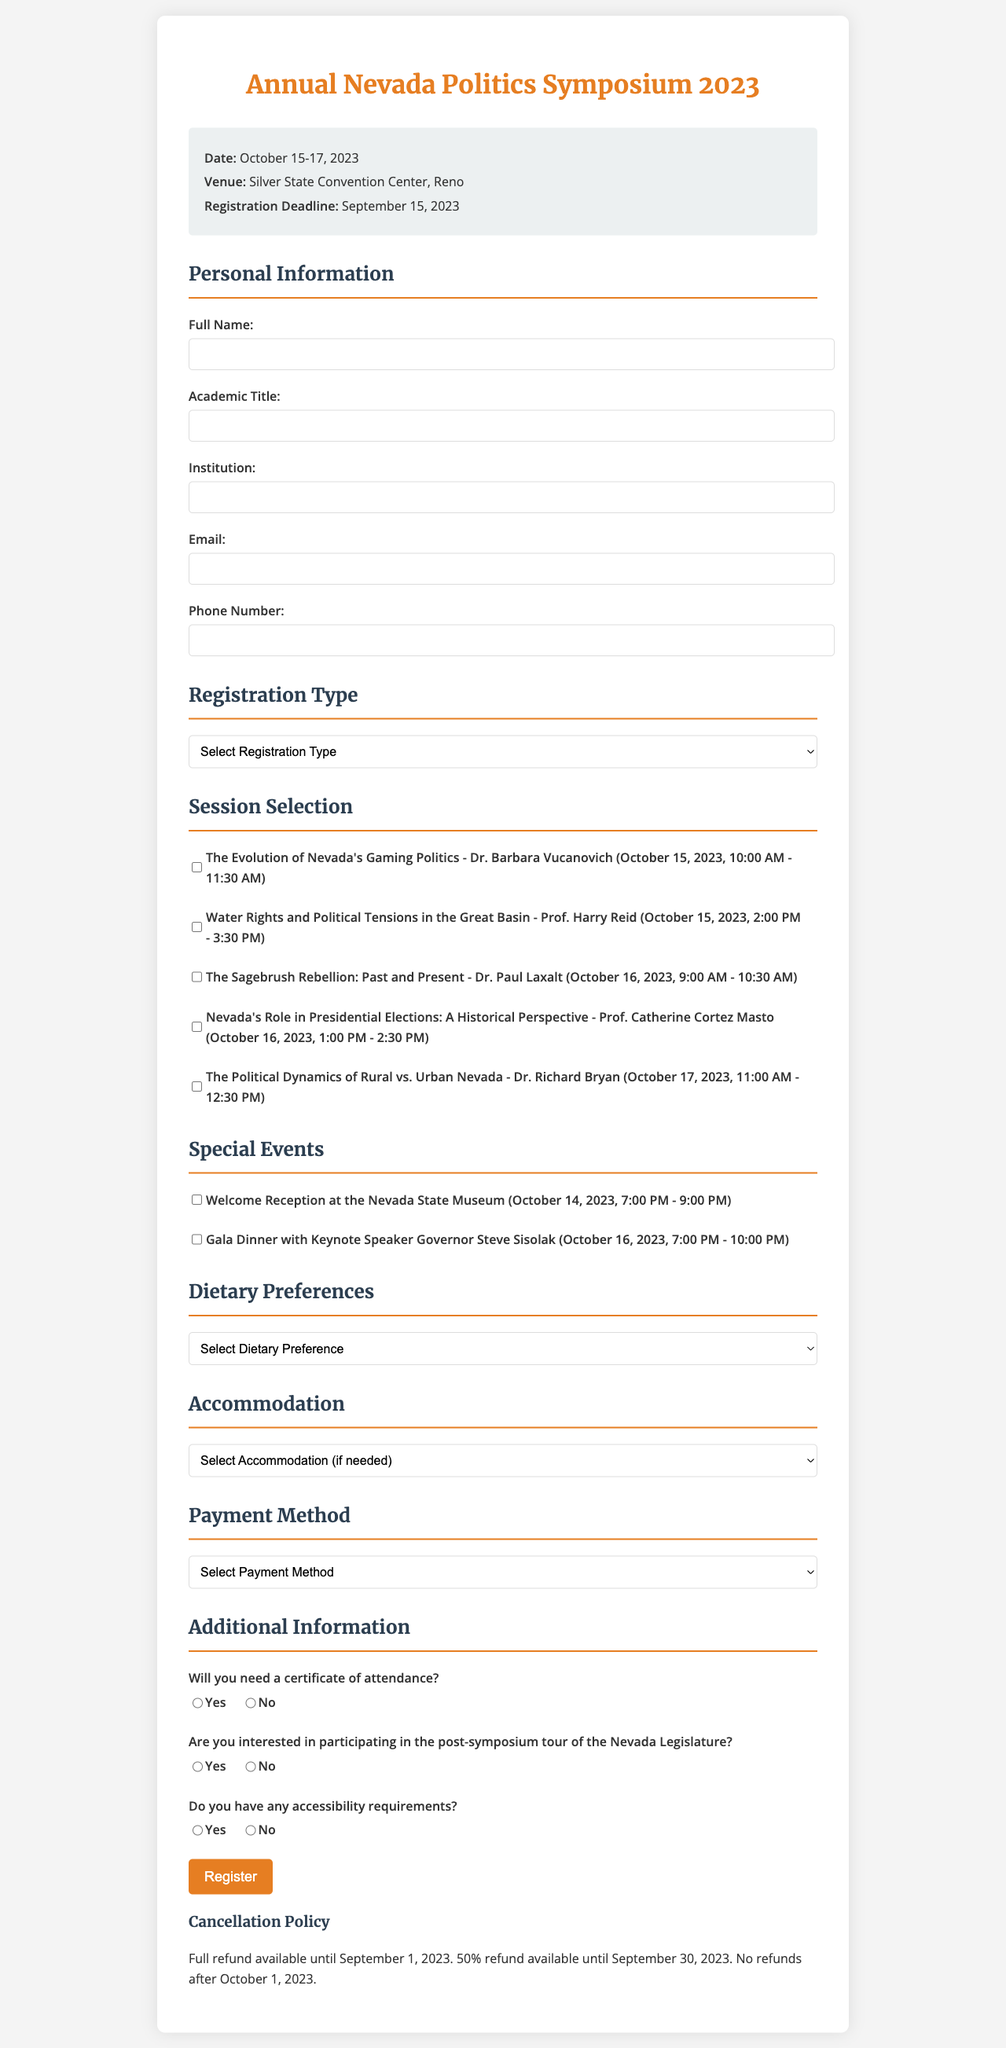what is the event name? The name of the event is specified at the top of the registration form.
Answer: Annual Nevada Politics Symposium 2023 when is the registration deadline? The registration deadline is clearly indicated in the document.
Answer: September 15, 2023 who is speaking at the session titled "The Sagebrush Rebellion: Past and Present"? The speaker for each session is listed alongside the session title in the documents.
Answer: Dr. Paul Laxalt what is the date of the Gala Dinner? The date of the Gala Dinner is specified in the special events section of the document.
Answer: October 16, 2023 how many sessions can attendees select? The number of sessions available for selection is indicated by the sessions listed in the document.
Answer: Five what dietary preference options are provided? The options for dietary preferences are clearly listed in the document.
Answer: No restrictions, Vegetarian, Vegan, Gluten-free, Kosher, Halal what payment methods are available? The available payment methods are specified in the document's payment section.
Answer: Credit Card, PayPal, Bank Transfer, Check is there a certificate of attendance available? The additional information section includes a question about the certificate of attendance.
Answer: Yes what is the accommodation option mentioned first in the list? The first accommodation option is listed at the beginning of the accommodation section.
Answer: Grand Sierra Resort 